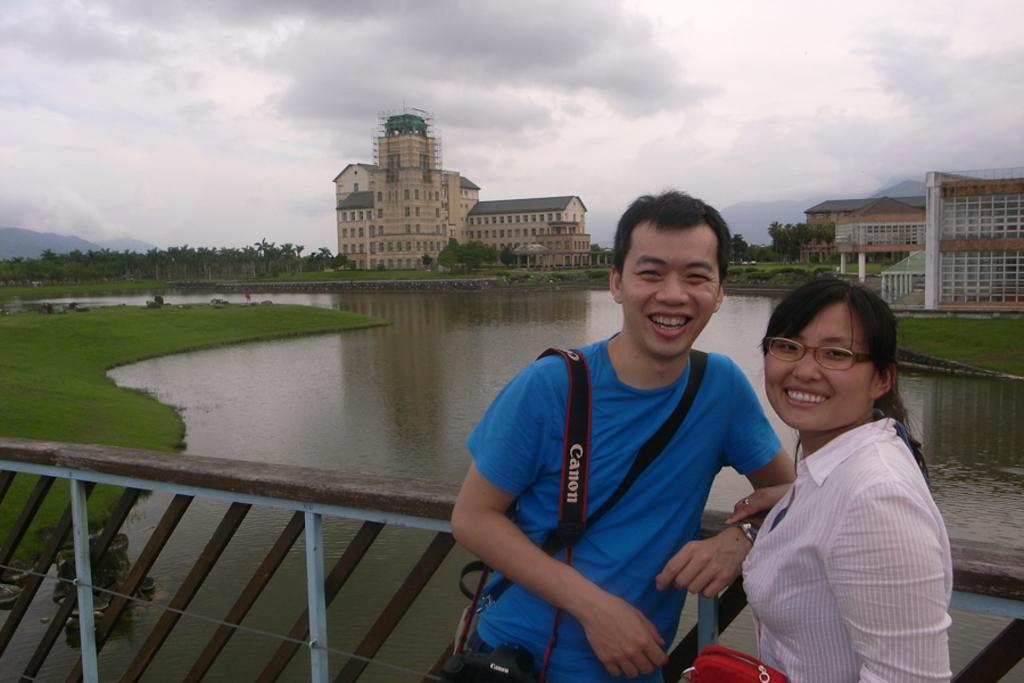<image>
Offer a succinct explanation of the picture presented. Couple posing for a picture with the guy wearing a strap that says Canon. 